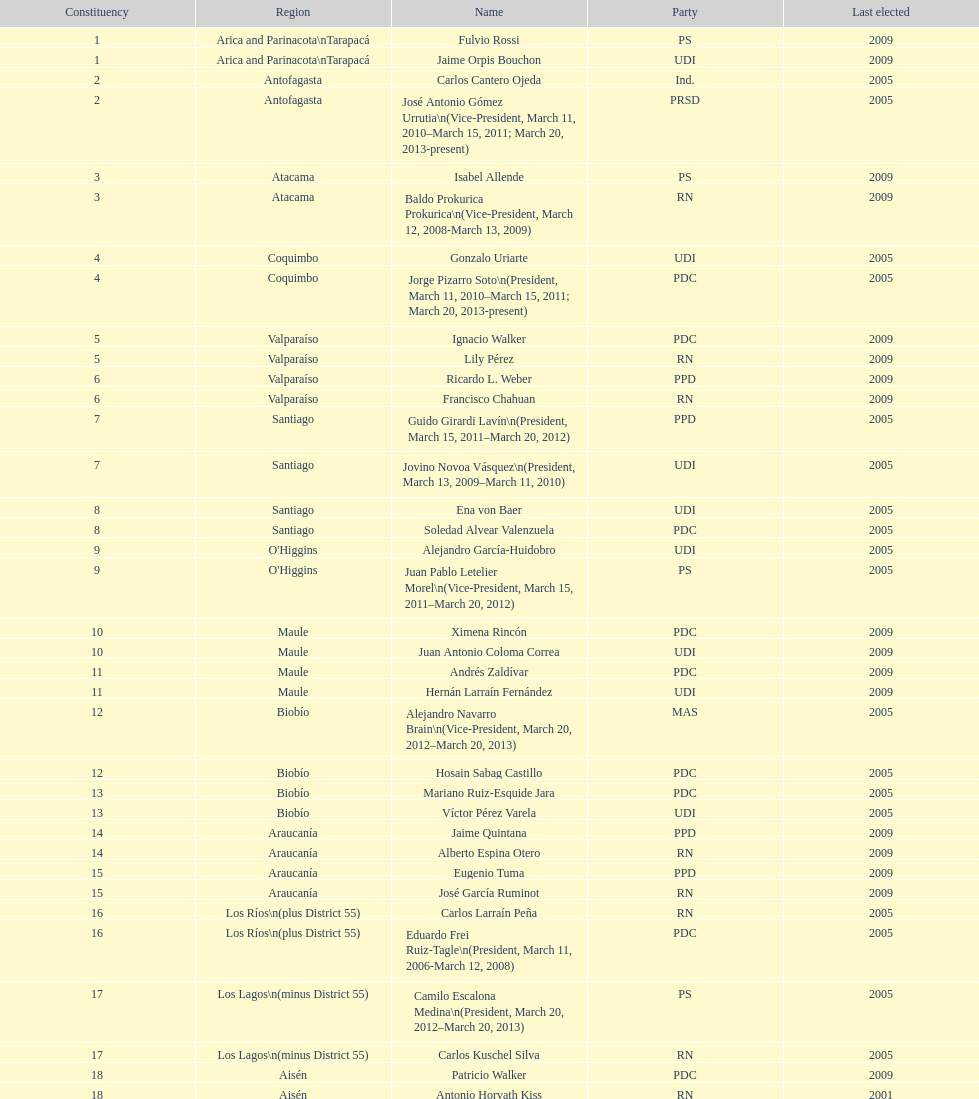In which party was jaime quintana involved? PPD. 